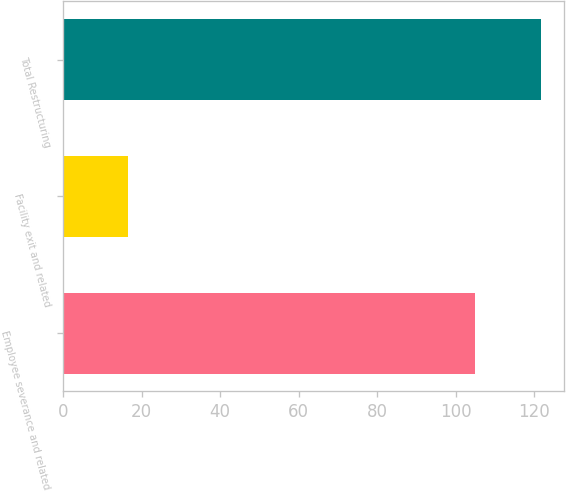<chart> <loc_0><loc_0><loc_500><loc_500><bar_chart><fcel>Employee severance and related<fcel>Facility exit and related<fcel>Total Restructuring<nl><fcel>105<fcel>16.6<fcel>121.6<nl></chart> 